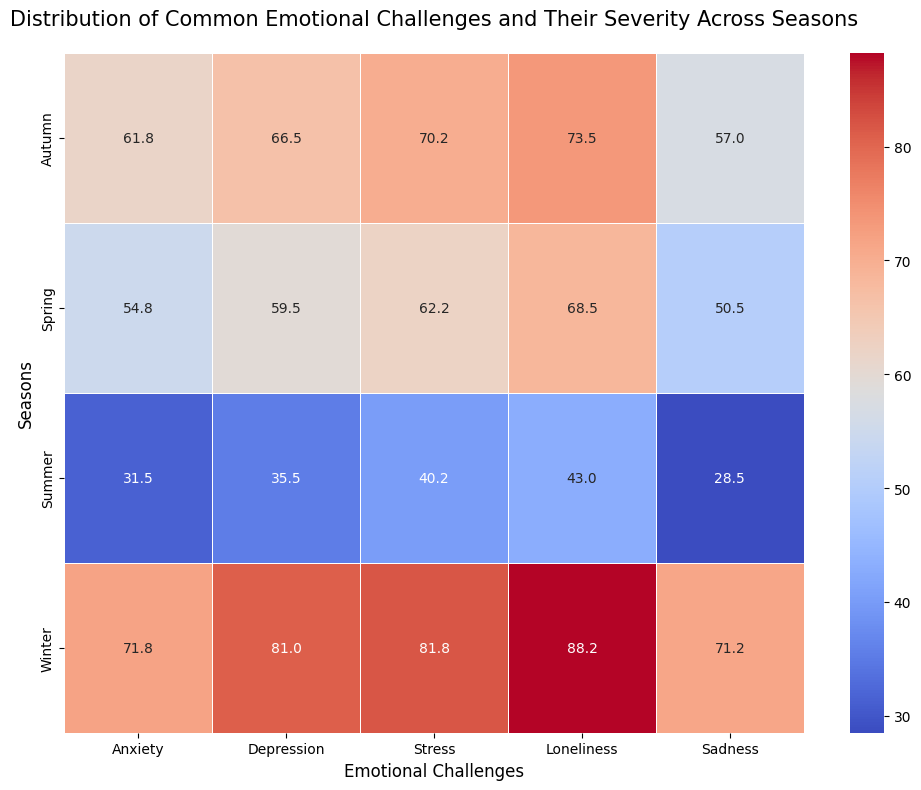What season has the highest average severity of loneliness? To determine the season with the highest average severity of loneliness, we need to look at the values in the row corresponding to "Loneliness". Winter has the highest values of loneliness among all seasons with values close to 88 to 91 on average.
Answer: Winter Between autumn and spring, which season shows higher average severity for anxiety? To compare the severity of anxiety between autumn and spring, look at the "Anxiety" values for each. Autumn shows values around 60-64, while spring has values around 52-58. Hence, autumn has higher averages.
Answer: Autumn What's the difference in the average severity of stress between winter and summer? Calculate the difference by subtracting the average stress in summer from that in winter. Winter stress averages are between 78-85, while summer stress averages are 40-42. The difference is close to 40.
Answer: Approximately 40 Which emotional challenge has the greatest difference in average severity between winter and summer? Compare the values for winter and summer across all emotional challenges. The highest difference can be seen in Loneliness, with winter values around 85-91 and summer values around 40-45.
Answer: Loneliness If we sum the average severities of depression in winter and spring, what is the total? Identify the average severities of depression in winter and spring and add them up. Winter is around 81-88 and spring around 57-62. Sum these averages to get a total close to 139-150.
Answer: Approximately 139-150 Is the average severity of sadness higher in autumn or winter? Compare the "Sadness" values for autumn and winter. Autumn shows values around 55-60 while winter shows values around 70-78. Winter has a higher average severity.
Answer: Winter What is the average severity of emotional challenges in summer for anxiety and sadness combined? Add the average severity values of anxiety and sadness in summer and then find the mean. Anxiety is around 30-33 and sadness around 27-30. Sum these to get around 60-63, then divide by 2 for an average of around 30-31.
Answer: Approximately 30-31 